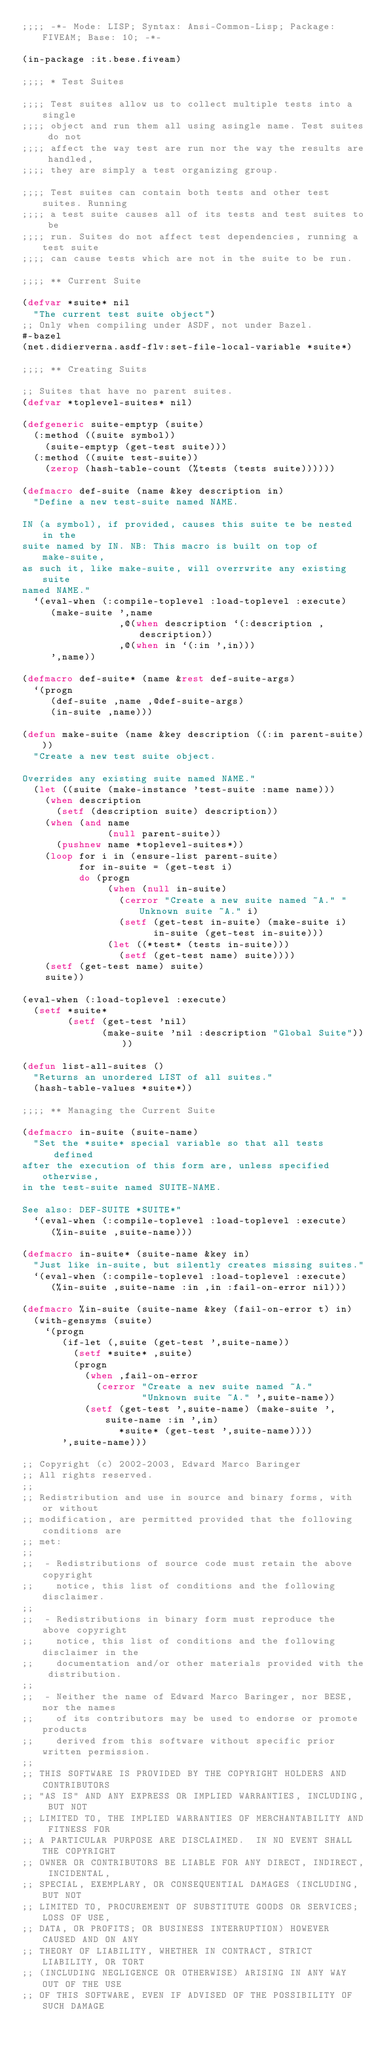<code> <loc_0><loc_0><loc_500><loc_500><_Lisp_>;;;; -*- Mode: LISP; Syntax: Ansi-Common-Lisp; Package: FIVEAM; Base: 10; -*-

(in-package :it.bese.fiveam)

;;;; * Test Suites

;;;; Test suites allow us to collect multiple tests into a single
;;;; object and run them all using asingle name. Test suites do not
;;;; affect the way test are run nor the way the results are handled,
;;;; they are simply a test organizing group.

;;;; Test suites can contain both tests and other test suites. Running
;;;; a test suite causes all of its tests and test suites to be
;;;; run. Suites do not affect test dependencies, running a test suite
;;;; can cause tests which are not in the suite to be run.

;;;; ** Current Suite

(defvar *suite* nil
  "The current test suite object")
;; Only when compiling under ASDF, not under Bazel.
#-bazel
(net.didierverna.asdf-flv:set-file-local-variable *suite*)

;;;; ** Creating Suits

;; Suites that have no parent suites.
(defvar *toplevel-suites* nil)

(defgeneric suite-emptyp (suite)
  (:method ((suite symbol))
    (suite-emptyp (get-test suite)))
  (:method ((suite test-suite))
    (zerop (hash-table-count (%tests (tests suite))))))

(defmacro def-suite (name &key description in)
  "Define a new test-suite named NAME.

IN (a symbol), if provided, causes this suite te be nested in the
suite named by IN. NB: This macro is built on top of make-suite,
as such it, like make-suite, will overrwrite any existing suite
named NAME."
  `(eval-when (:compile-toplevel :load-toplevel :execute)
     (make-suite ',name
                 ,@(when description `(:description ,description))
                 ,@(when in `(:in ',in)))
     ',name))

(defmacro def-suite* (name &rest def-suite-args)
  `(progn
     (def-suite ,name ,@def-suite-args)
     (in-suite ,name)))

(defun make-suite (name &key description ((:in parent-suite)))
  "Create a new test suite object.

Overrides any existing suite named NAME."
  (let ((suite (make-instance 'test-suite :name name)))
    (when description
      (setf (description suite) description))
    (when (and name
               (null parent-suite))
      (pushnew name *toplevel-suites*))
    (loop for i in (ensure-list parent-suite)
          for in-suite = (get-test i)
          do (progn
               (when (null in-suite)
                 (cerror "Create a new suite named ~A." "Unknown suite ~A." i)
                 (setf (get-test in-suite) (make-suite i)
                       in-suite (get-test in-suite)))
               (let ((*test* (tests in-suite)))
                 (setf (get-test name) suite))))
    (setf (get-test name) suite)
    suite))

(eval-when (:load-toplevel :execute)
  (setf *suite*
        (setf (get-test 'nil)
              (make-suite 'nil :description "Global Suite"))))

(defun list-all-suites ()
  "Returns an unordered LIST of all suites."
  (hash-table-values *suite*))

;;;; ** Managing the Current Suite

(defmacro in-suite (suite-name)
  "Set the *suite* special variable so that all tests defined
after the execution of this form are, unless specified otherwise,
in the test-suite named SUITE-NAME.

See also: DEF-SUITE *SUITE*"
  `(eval-when (:compile-toplevel :load-toplevel :execute)
     (%in-suite ,suite-name)))

(defmacro in-suite* (suite-name &key in)
  "Just like in-suite, but silently creates missing suites."
  `(eval-when (:compile-toplevel :load-toplevel :execute)
     (%in-suite ,suite-name :in ,in :fail-on-error nil)))

(defmacro %in-suite (suite-name &key (fail-on-error t) in)
  (with-gensyms (suite)
    `(progn
       (if-let (,suite (get-test ',suite-name))
         (setf *suite* ,suite)
         (progn
           (when ,fail-on-error
             (cerror "Create a new suite named ~A."
                     "Unknown suite ~A." ',suite-name))
           (setf (get-test ',suite-name) (make-suite ',suite-name :in ',in)
                 *suite* (get-test ',suite-name))))
       ',suite-name)))

;; Copyright (c) 2002-2003, Edward Marco Baringer
;; All rights reserved.
;;
;; Redistribution and use in source and binary forms, with or without
;; modification, are permitted provided that the following conditions are
;; met:
;;
;;  - Redistributions of source code must retain the above copyright
;;    notice, this list of conditions and the following disclaimer.
;;
;;  - Redistributions in binary form must reproduce the above copyright
;;    notice, this list of conditions and the following disclaimer in the
;;    documentation and/or other materials provided with the distribution.
;;
;;  - Neither the name of Edward Marco Baringer, nor BESE, nor the names
;;    of its contributors may be used to endorse or promote products
;;    derived from this software without specific prior written permission.
;;
;; THIS SOFTWARE IS PROVIDED BY THE COPYRIGHT HOLDERS AND CONTRIBUTORS
;; "AS IS" AND ANY EXPRESS OR IMPLIED WARRANTIES, INCLUDING, BUT NOT
;; LIMITED TO, THE IMPLIED WARRANTIES OF MERCHANTABILITY AND FITNESS FOR
;; A PARTICULAR PURPOSE ARE DISCLAIMED.  IN NO EVENT SHALL THE COPYRIGHT
;; OWNER OR CONTRIBUTORS BE LIABLE FOR ANY DIRECT, INDIRECT, INCIDENTAL,
;; SPECIAL, EXEMPLARY, OR CONSEQUENTIAL DAMAGES (INCLUDING, BUT NOT
;; LIMITED TO, PROCUREMENT OF SUBSTITUTE GOODS OR SERVICES; LOSS OF USE,
;; DATA, OR PROFITS; OR BUSINESS INTERRUPTION) HOWEVER CAUSED AND ON ANY
;; THEORY OF LIABILITY, WHETHER IN CONTRACT, STRICT LIABILITY, OR TORT
;; (INCLUDING NEGLIGENCE OR OTHERWISE) ARISING IN ANY WAY OUT OF THE USE
;; OF THIS SOFTWARE, EVEN IF ADVISED OF THE POSSIBILITY OF SUCH DAMAGE
</code> 